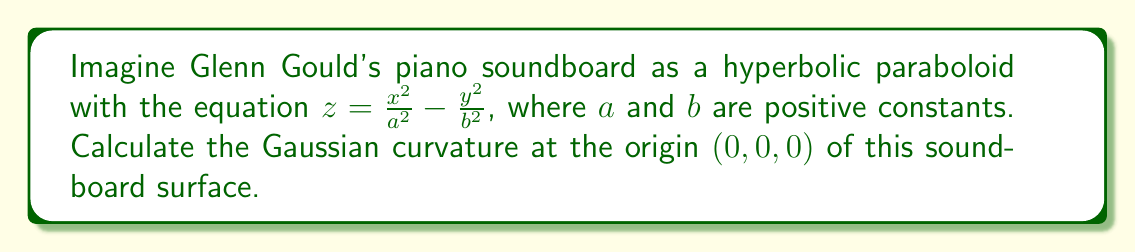Help me with this question. To find the Gaussian curvature of the piano soundboard at the origin, we'll follow these steps:

1) The Gaussian curvature $K$ is given by $K = \frac{LN - M^2}{EG - F^2}$, where $E$, $F$, $G$ are the coefficients of the first fundamental form, and $L$, $M$, $N$ are the coefficients of the second fundamental form.

2) For a surface $z = f(x,y)$, we have:
   $E = 1 + (\frac{\partial f}{\partial x})^2$
   $F = \frac{\partial f}{\partial x} \frac{\partial f}{\partial y}$
   $G = 1 + (\frac{\partial f}{\partial y})^2$
   $L = \frac{\frac{\partial^2 f}{\partial x^2}}{\sqrt{1+(\frac{\partial f}{\partial x})^2+(\frac{\partial f}{\partial y})^2}}$
   $M = \frac{\frac{\partial^2 f}{\partial x \partial y}}{\sqrt{1+(\frac{\partial f}{\partial x})^2+(\frac{\partial f}{\partial y})^2}}$
   $N = \frac{\frac{\partial^2 f}{\partial y^2}}{\sqrt{1+(\frac{\partial f}{\partial x})^2+(\frac{\partial f}{\partial y})^2}}$

3) For our surface $f(x,y) = \frac{x^2}{a^2} - \frac{y^2}{b^2}$, we calculate:
   $\frac{\partial f}{\partial x} = \frac{2x}{a^2}$
   $\frac{\partial f}{\partial y} = -\frac{2y}{b^2}$
   $\frac{\partial^2 f}{\partial x^2} = \frac{2}{a^2}$
   $\frac{\partial^2 f}{\partial y^2} = -\frac{2}{b^2}$
   $\frac{\partial^2 f}{\partial x \partial y} = 0$

4) At the origin $(0,0,0)$, we have:
   $E = 1$, $F = 0$, $G = 1$
   $L = \frac{2}{a^2}$, $M = 0$, $N = -\frac{2}{b^2}$

5) Substituting these values into the formula for Gaussian curvature:

   $K = \frac{LN - M^2}{EG - F^2} = \frac{(\frac{2}{a^2})(-\frac{2}{b^2}) - 0^2}{(1)(1) - 0^2} = -\frac{4}{a^2b^2}$

Therefore, the Gaussian curvature at the origin of the piano soundboard is $-\frac{4}{a^2b^2}$.
Answer: $-\frac{4}{a^2b^2}$ 